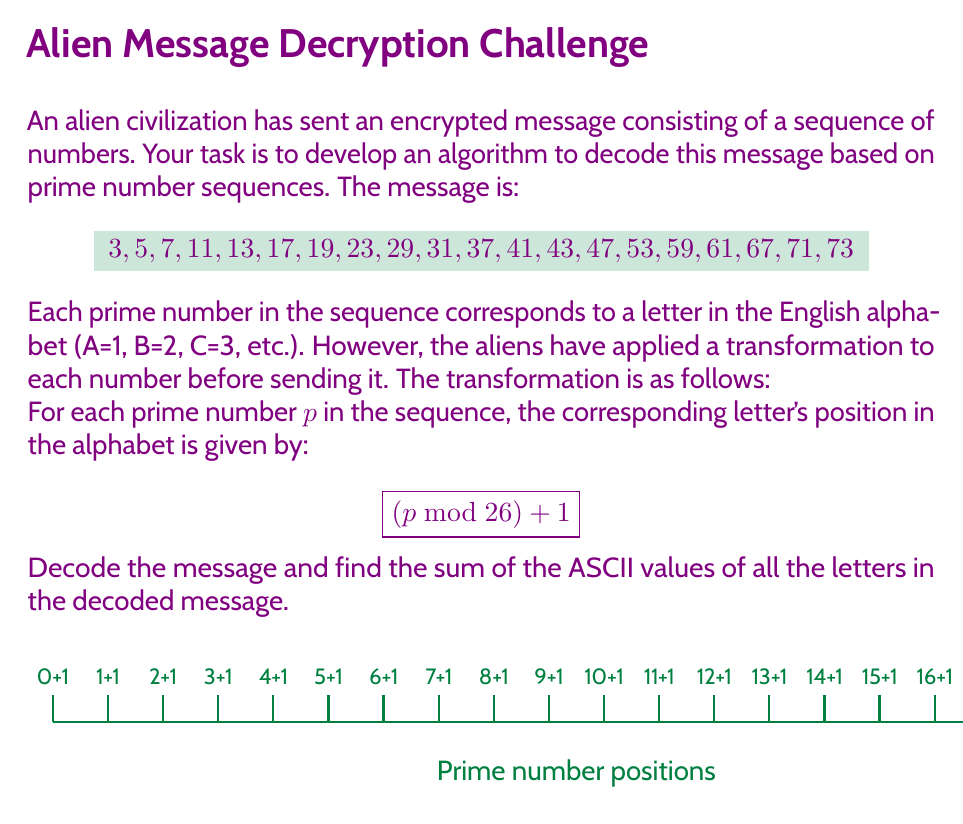Give your solution to this math problem. Let's approach this step-by-step:

1) First, we need to apply the transformation to each prime number in the sequence:

   $3 \bmod 26 + 1 = 4$
   $5 \bmod 26 + 1 = 6$
   $7 \bmod 26 + 1 = 8$
   $11 \bmod 26 + 1 = 12$
   $13 \bmod 26 + 1 = 14$
   $17 \bmod 26 + 1 = 18$
   $19 \bmod 26 + 1 = 20$
   $23 \bmod 26 + 1 = 24$
   $29 \bmod 26 + 1 = 4$
   $31 \bmod 26 + 1 = 6$
   $37 \bmod 26 + 1 = 12$
   $41 \bmod 26 + 1 = 16$
   $43 \bmod 26 + 1 = 18$
   $47 \bmod 26 + 1 = 22$
   $53 \bmod 26 + 1 = 2$
   $59 \bmod 26 + 1 = 8$
   $61 \bmod 26 + 1 = 10$
   $67 \bmod 26 + 1 = 16$
   $71 \bmod 26 + 1 = 20$
   $73 \bmod 26 + 1 = 22$

2) Now, we can convert these numbers to letters (remember, A=1, B=2, etc.):

   4, 6, 8, 12, 14, 18, 20, 24, 4, 6, 12, 16, 18, 22, 2, 8, 10, 16, 20, 22
   D, F, H, L, N, R, T, X, D, F, L, P, R, V, B, H, J, P, T, V

3) The decoded message is: DFHLNRTXDFLPRVBHJPTV

4) Now, we need to find the sum of the ASCII values of these letters. ASCII values for uppercase letters are:
   A = 65, B = 66, C = 67, ..., Z = 90

   So, we sum:
   68 + 70 + 72 + 76 + 78 + 82 + 84 + 88 + 68 + 70 + 76 + 80 + 82 + 86 + 66 + 72 + 74 + 80 + 84 + 86 = 1562

Therefore, the sum of the ASCII values of all letters in the decoded message is 1562.
Answer: 1562 